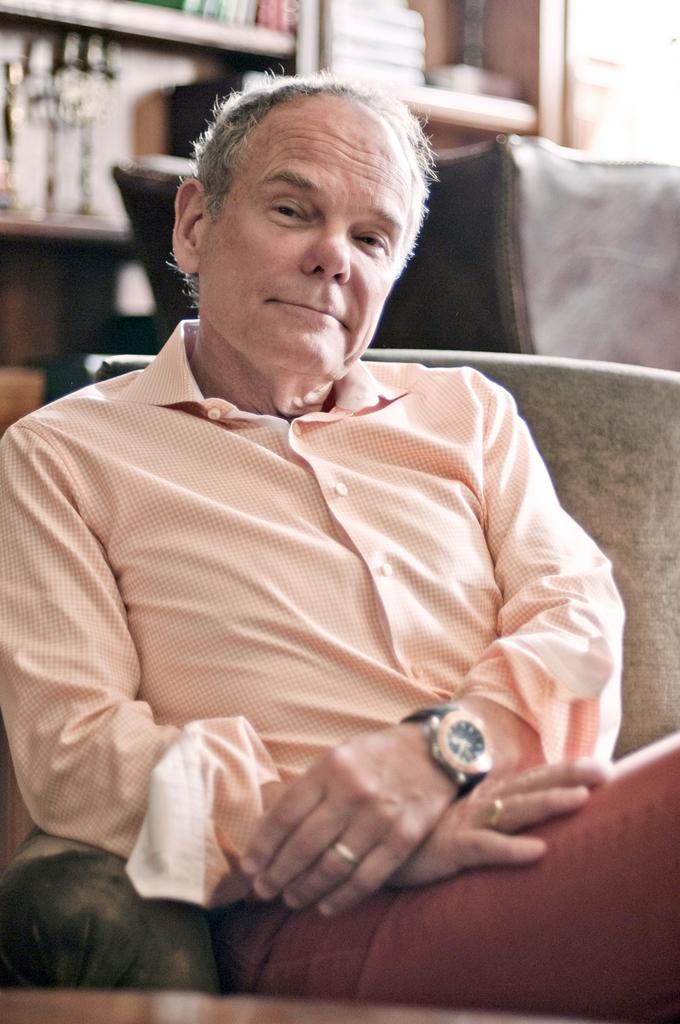Who is the main subject in the image? There is a man in the center of the image. What is the man doing or sitting on? The man is on a couch. What can be seen in the background of the image? There are books in the shelves and another couch in the background. What type of road can be seen in the image? There is no road present in the image; it features a man on a couch with books in the background. 